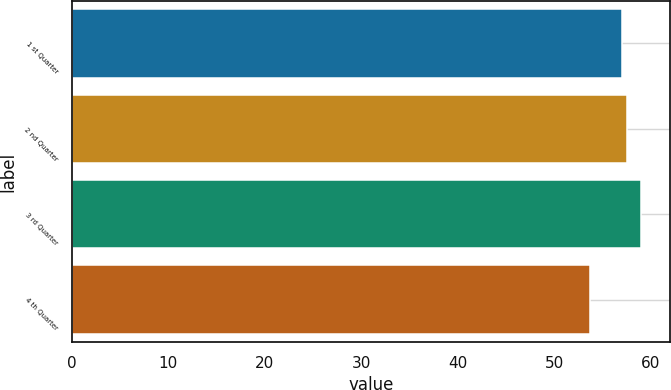Convert chart to OTSL. <chart><loc_0><loc_0><loc_500><loc_500><bar_chart><fcel>1 st Quarter<fcel>2 nd Quarter<fcel>3 rd Quarter<fcel>4 th Quarter<nl><fcel>56.99<fcel>57.53<fcel>59.01<fcel>53.63<nl></chart> 